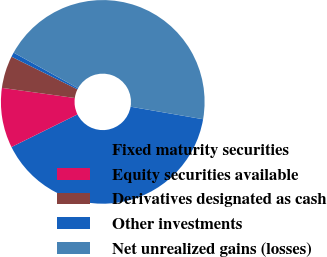Convert chart. <chart><loc_0><loc_0><loc_500><loc_500><pie_chart><fcel>Fixed maturity securities<fcel>Equity securities available<fcel>Derivatives designated as cash<fcel>Other investments<fcel>Net unrealized gains (losses)<nl><fcel>39.96%<fcel>9.51%<fcel>5.12%<fcel>0.72%<fcel>44.69%<nl></chart> 